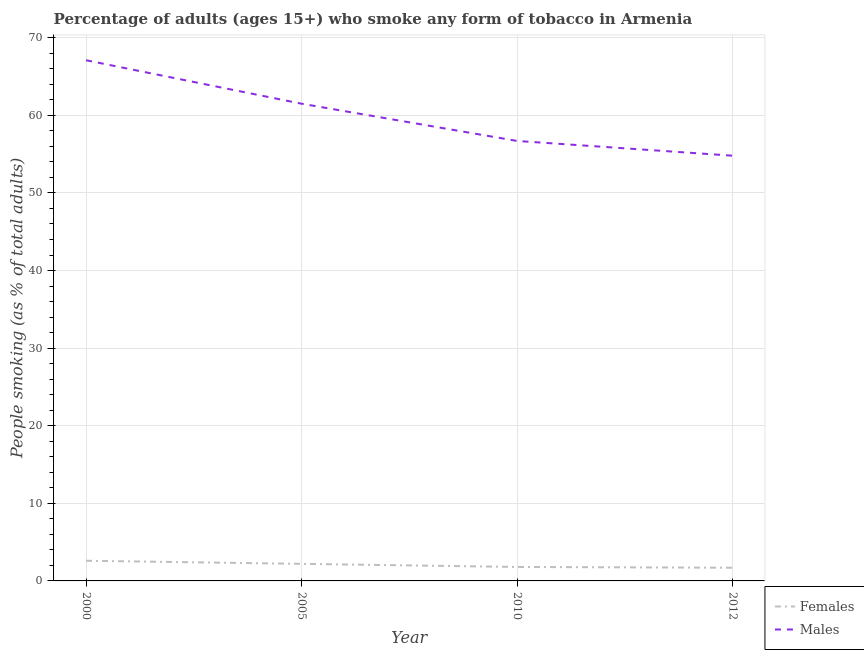How many different coloured lines are there?
Provide a succinct answer. 2. Does the line corresponding to percentage of males who smoke intersect with the line corresponding to percentage of females who smoke?
Offer a very short reply. No. Is the number of lines equal to the number of legend labels?
Provide a short and direct response. Yes. What is the percentage of males who smoke in 2000?
Ensure brevity in your answer.  67.1. Across all years, what is the maximum percentage of males who smoke?
Offer a terse response. 67.1. Across all years, what is the minimum percentage of males who smoke?
Make the answer very short. 54.8. In which year was the percentage of males who smoke minimum?
Your answer should be compact. 2012. What is the total percentage of females who smoke in the graph?
Give a very brief answer. 8.3. What is the difference between the percentage of females who smoke in 2000 and that in 2012?
Provide a short and direct response. 0.9. What is the difference between the percentage of females who smoke in 2010 and the percentage of males who smoke in 2000?
Ensure brevity in your answer.  -65.3. What is the average percentage of males who smoke per year?
Offer a very short reply. 60.03. In the year 2000, what is the difference between the percentage of females who smoke and percentage of males who smoke?
Ensure brevity in your answer.  -64.5. What is the ratio of the percentage of males who smoke in 2005 to that in 2010?
Your answer should be compact. 1.08. Is the percentage of females who smoke in 2005 less than that in 2012?
Offer a very short reply. No. What is the difference between the highest and the second highest percentage of females who smoke?
Give a very brief answer. 0.4. What is the difference between the highest and the lowest percentage of females who smoke?
Provide a short and direct response. 0.9. In how many years, is the percentage of males who smoke greater than the average percentage of males who smoke taken over all years?
Offer a very short reply. 2. Is the sum of the percentage of males who smoke in 2000 and 2012 greater than the maximum percentage of females who smoke across all years?
Offer a terse response. Yes. How many lines are there?
Keep it short and to the point. 2. What is the difference between two consecutive major ticks on the Y-axis?
Your answer should be very brief. 10. Are the values on the major ticks of Y-axis written in scientific E-notation?
Provide a short and direct response. No. How many legend labels are there?
Ensure brevity in your answer.  2. How are the legend labels stacked?
Offer a very short reply. Vertical. What is the title of the graph?
Keep it short and to the point. Percentage of adults (ages 15+) who smoke any form of tobacco in Armenia. Does "Non-solid fuel" appear as one of the legend labels in the graph?
Offer a very short reply. No. What is the label or title of the Y-axis?
Your answer should be compact. People smoking (as % of total adults). What is the People smoking (as % of total adults) of Females in 2000?
Give a very brief answer. 2.6. What is the People smoking (as % of total adults) in Males in 2000?
Give a very brief answer. 67.1. What is the People smoking (as % of total adults) in Males in 2005?
Keep it short and to the point. 61.5. What is the People smoking (as % of total adults) in Males in 2010?
Give a very brief answer. 56.7. What is the People smoking (as % of total adults) of Males in 2012?
Offer a very short reply. 54.8. Across all years, what is the maximum People smoking (as % of total adults) in Females?
Provide a short and direct response. 2.6. Across all years, what is the maximum People smoking (as % of total adults) in Males?
Ensure brevity in your answer.  67.1. Across all years, what is the minimum People smoking (as % of total adults) in Females?
Make the answer very short. 1.7. Across all years, what is the minimum People smoking (as % of total adults) in Males?
Offer a terse response. 54.8. What is the total People smoking (as % of total adults) of Males in the graph?
Provide a succinct answer. 240.1. What is the difference between the People smoking (as % of total adults) of Females in 2000 and that in 2005?
Your response must be concise. 0.4. What is the difference between the People smoking (as % of total adults) of Males in 2000 and that in 2005?
Make the answer very short. 5.6. What is the difference between the People smoking (as % of total adults) of Females in 2000 and that in 2010?
Your response must be concise. 0.8. What is the difference between the People smoking (as % of total adults) of Females in 2000 and that in 2012?
Offer a terse response. 0.9. What is the difference between the People smoking (as % of total adults) in Males in 2000 and that in 2012?
Your answer should be very brief. 12.3. What is the difference between the People smoking (as % of total adults) in Males in 2005 and that in 2010?
Your answer should be very brief. 4.8. What is the difference between the People smoking (as % of total adults) in Females in 2005 and that in 2012?
Ensure brevity in your answer.  0.5. What is the difference between the People smoking (as % of total adults) in Females in 2010 and that in 2012?
Offer a terse response. 0.1. What is the difference between the People smoking (as % of total adults) of Females in 2000 and the People smoking (as % of total adults) of Males in 2005?
Provide a succinct answer. -58.9. What is the difference between the People smoking (as % of total adults) in Females in 2000 and the People smoking (as % of total adults) in Males in 2010?
Offer a very short reply. -54.1. What is the difference between the People smoking (as % of total adults) in Females in 2000 and the People smoking (as % of total adults) in Males in 2012?
Your response must be concise. -52.2. What is the difference between the People smoking (as % of total adults) in Females in 2005 and the People smoking (as % of total adults) in Males in 2010?
Your answer should be compact. -54.5. What is the difference between the People smoking (as % of total adults) of Females in 2005 and the People smoking (as % of total adults) of Males in 2012?
Provide a succinct answer. -52.6. What is the difference between the People smoking (as % of total adults) in Females in 2010 and the People smoking (as % of total adults) in Males in 2012?
Offer a terse response. -53. What is the average People smoking (as % of total adults) of Females per year?
Ensure brevity in your answer.  2.08. What is the average People smoking (as % of total adults) in Males per year?
Provide a succinct answer. 60.02. In the year 2000, what is the difference between the People smoking (as % of total adults) in Females and People smoking (as % of total adults) in Males?
Offer a very short reply. -64.5. In the year 2005, what is the difference between the People smoking (as % of total adults) of Females and People smoking (as % of total adults) of Males?
Your answer should be very brief. -59.3. In the year 2010, what is the difference between the People smoking (as % of total adults) of Females and People smoking (as % of total adults) of Males?
Provide a short and direct response. -54.9. In the year 2012, what is the difference between the People smoking (as % of total adults) of Females and People smoking (as % of total adults) of Males?
Keep it short and to the point. -53.1. What is the ratio of the People smoking (as % of total adults) in Females in 2000 to that in 2005?
Your answer should be very brief. 1.18. What is the ratio of the People smoking (as % of total adults) in Males in 2000 to that in 2005?
Your answer should be compact. 1.09. What is the ratio of the People smoking (as % of total adults) in Females in 2000 to that in 2010?
Keep it short and to the point. 1.44. What is the ratio of the People smoking (as % of total adults) of Males in 2000 to that in 2010?
Provide a succinct answer. 1.18. What is the ratio of the People smoking (as % of total adults) in Females in 2000 to that in 2012?
Keep it short and to the point. 1.53. What is the ratio of the People smoking (as % of total adults) of Males in 2000 to that in 2012?
Your answer should be very brief. 1.22. What is the ratio of the People smoking (as % of total adults) of Females in 2005 to that in 2010?
Offer a terse response. 1.22. What is the ratio of the People smoking (as % of total adults) of Males in 2005 to that in 2010?
Your answer should be compact. 1.08. What is the ratio of the People smoking (as % of total adults) of Females in 2005 to that in 2012?
Your answer should be compact. 1.29. What is the ratio of the People smoking (as % of total adults) of Males in 2005 to that in 2012?
Provide a short and direct response. 1.12. What is the ratio of the People smoking (as % of total adults) in Females in 2010 to that in 2012?
Your answer should be very brief. 1.06. What is the ratio of the People smoking (as % of total adults) of Males in 2010 to that in 2012?
Your answer should be very brief. 1.03. What is the difference between the highest and the second highest People smoking (as % of total adults) in Females?
Offer a very short reply. 0.4. What is the difference between the highest and the second highest People smoking (as % of total adults) of Males?
Offer a terse response. 5.6. What is the difference between the highest and the lowest People smoking (as % of total adults) of Males?
Keep it short and to the point. 12.3. 